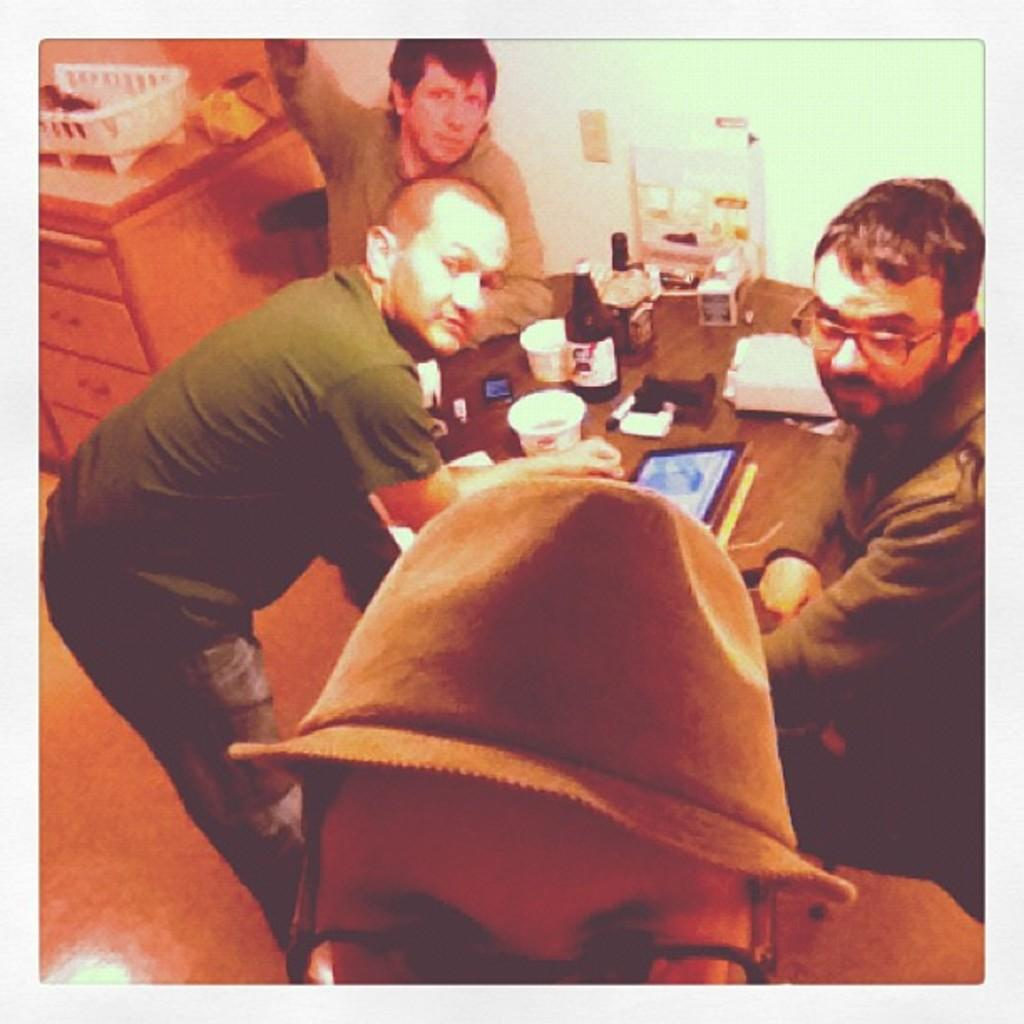How many people are in the image? There are four people in the image. What are the positions of the people in the image? Two of the people are standing, and two of the people are seated. What objects are on the table in the image? There is a bottle and two cups on the table. What type of thread is being used to sew the details on the people's clothing in the image? There is no thread or sewing visible in the image; the people's clothing is not being altered or created. 